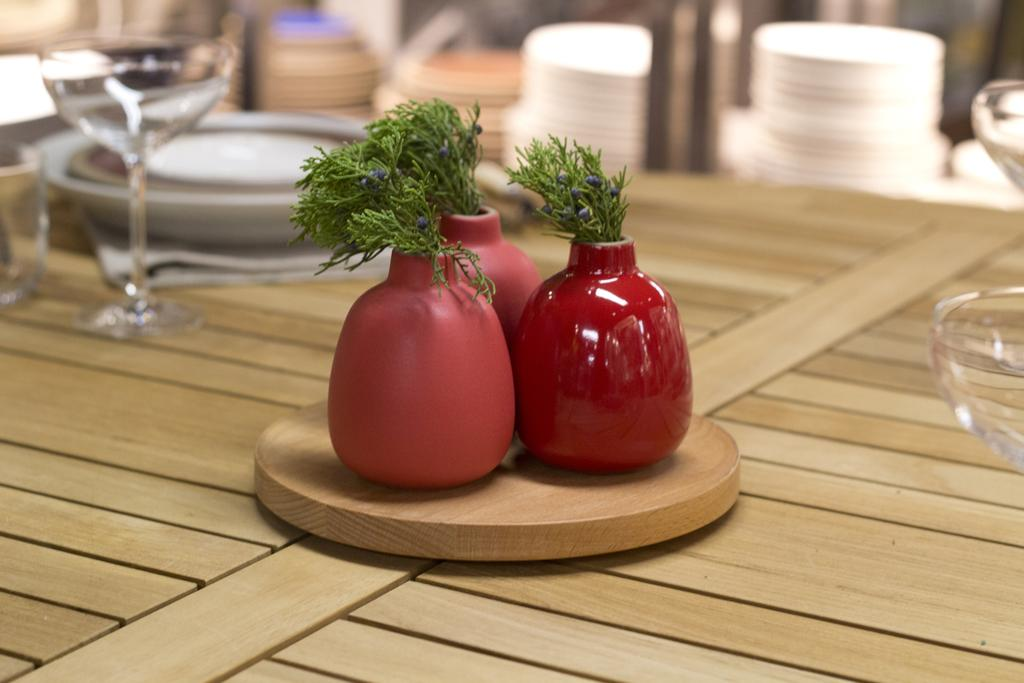What type of living organisms are in the image? There are plants in the image. What color is the pot that holds the plants? The plants are in a red-colored pot. How are the plants emphasized in the image? The plants are highlighted in the image. What type of furniture is present in the image? There is a table in the image. What items can be seen on the table? There are plates, glasses, and a bowl on the table. What type of pancake is being served on the table in the image? There is no pancake present in the image; the table contains plates, glasses, and a bowl. 